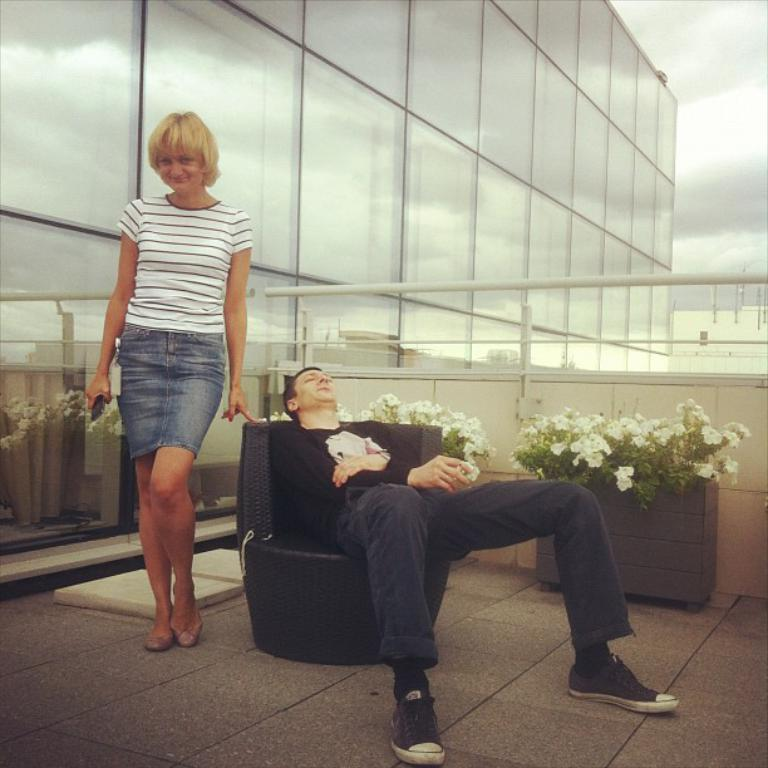What type of structure is visible in the image? There is a building in the image. Can you describe the people in the image? There is a woman standing and a person sitting in the image. What can be seen on the table or surface in the image? There is a flower vase with flowers in the image. How would you describe the weather based on the image? The sky is cloudy in the image, suggesting a potentially overcast or cloudy day. What type of quince juice is being served in the image? There is no mention of quince juice or any type of juice in the image. How many rabbits can be seen playing in the image? There are no rabbits present in the image. 